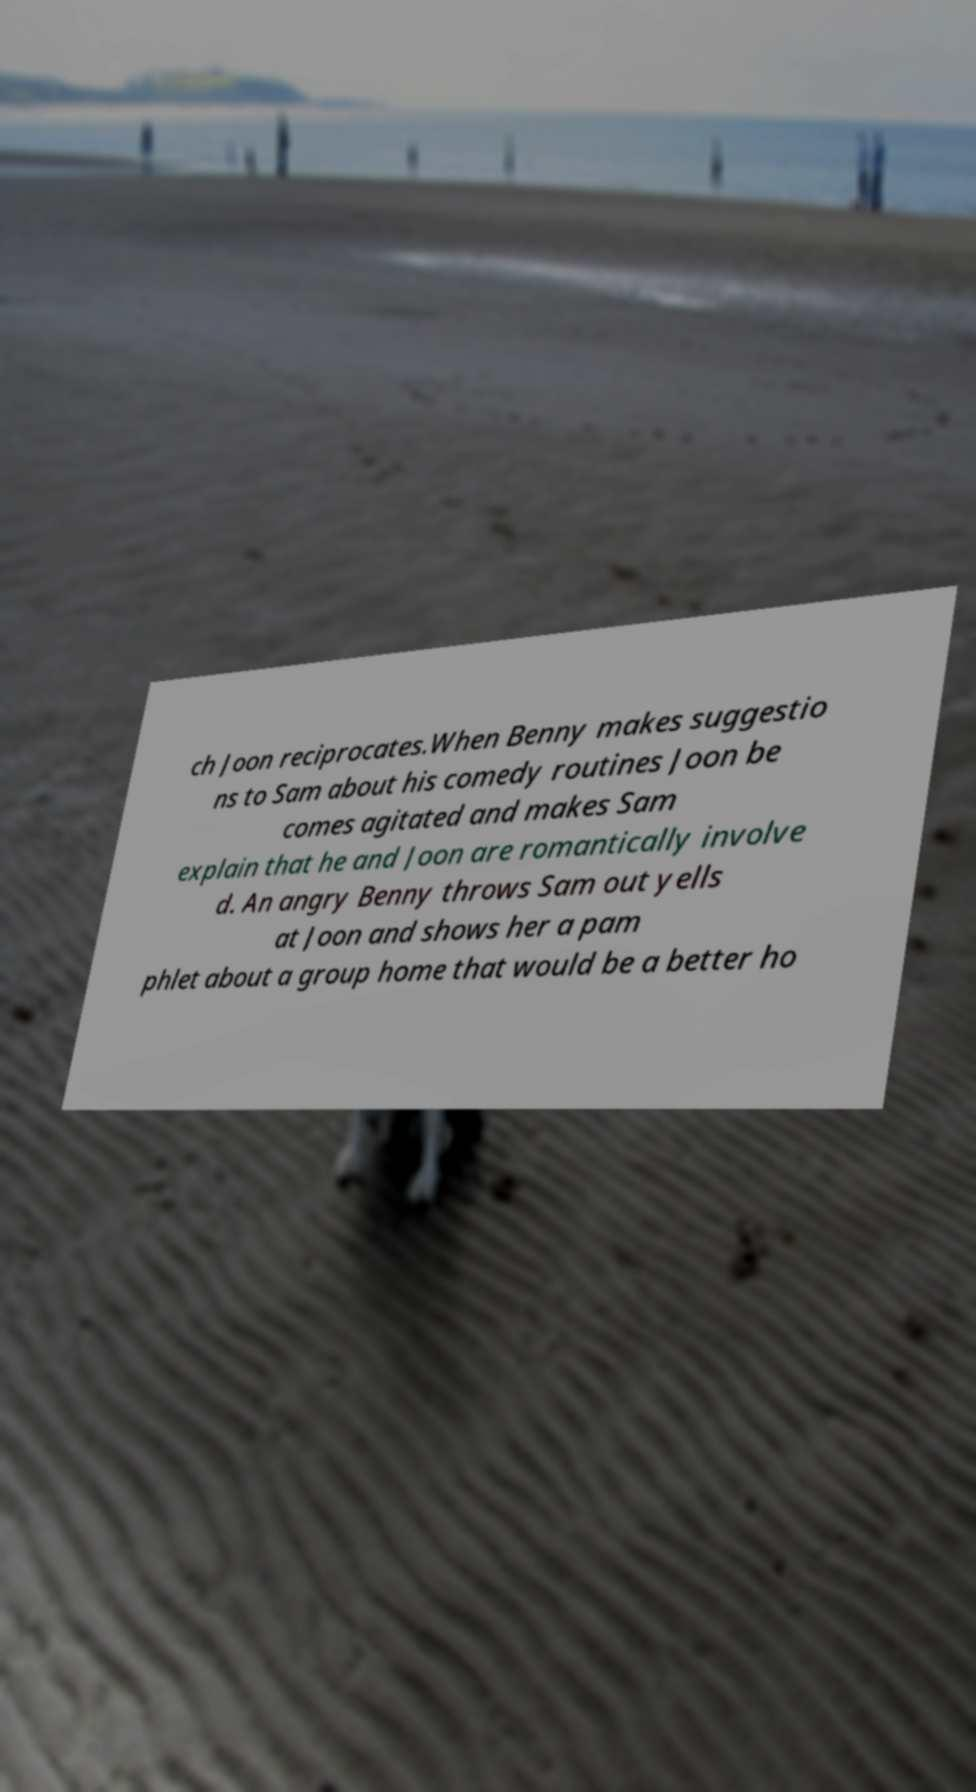Please read and relay the text visible in this image. What does it say? ch Joon reciprocates.When Benny makes suggestio ns to Sam about his comedy routines Joon be comes agitated and makes Sam explain that he and Joon are romantically involve d. An angry Benny throws Sam out yells at Joon and shows her a pam phlet about a group home that would be a better ho 